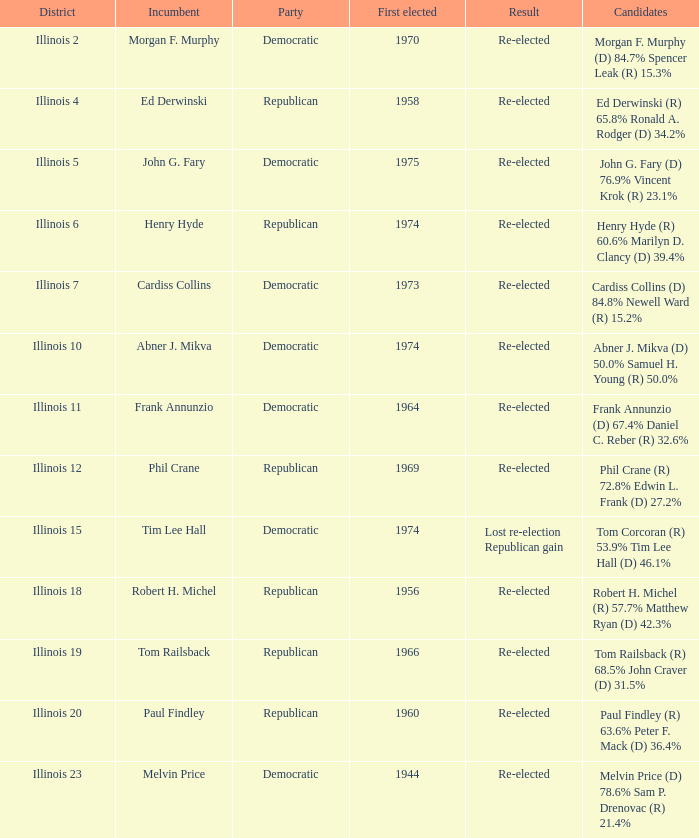Name the candidates for illinois 15 Tom Corcoran (R) 53.9% Tim Lee Hall (D) 46.1%. 